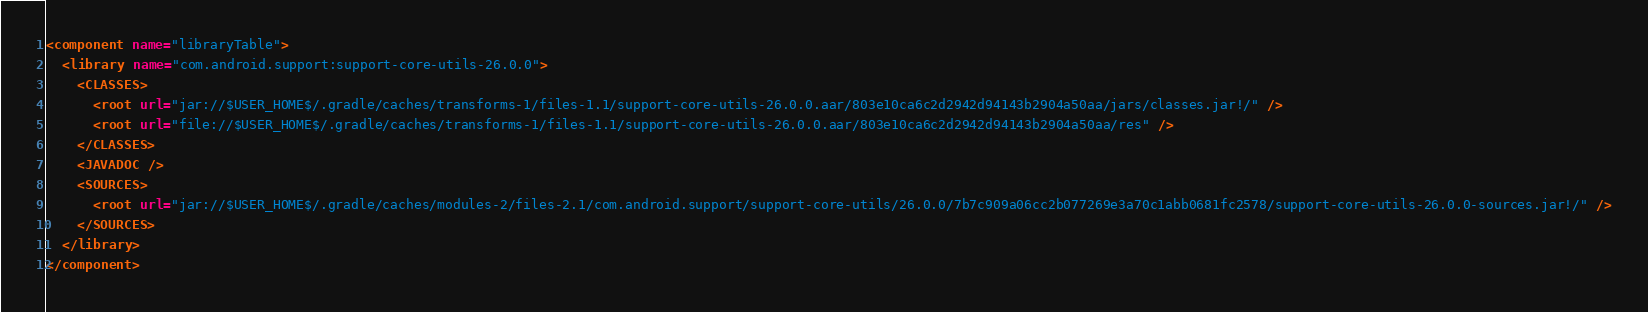<code> <loc_0><loc_0><loc_500><loc_500><_XML_><component name="libraryTable">
  <library name="com.android.support:support-core-utils-26.0.0">
    <CLASSES>
      <root url="jar://$USER_HOME$/.gradle/caches/transforms-1/files-1.1/support-core-utils-26.0.0.aar/803e10ca6c2d2942d94143b2904a50aa/jars/classes.jar!/" />
      <root url="file://$USER_HOME$/.gradle/caches/transforms-1/files-1.1/support-core-utils-26.0.0.aar/803e10ca6c2d2942d94143b2904a50aa/res" />
    </CLASSES>
    <JAVADOC />
    <SOURCES>
      <root url="jar://$USER_HOME$/.gradle/caches/modules-2/files-2.1/com.android.support/support-core-utils/26.0.0/7b7c909a06cc2b077269e3a70c1abb0681fc2578/support-core-utils-26.0.0-sources.jar!/" />
    </SOURCES>
  </library>
</component></code> 